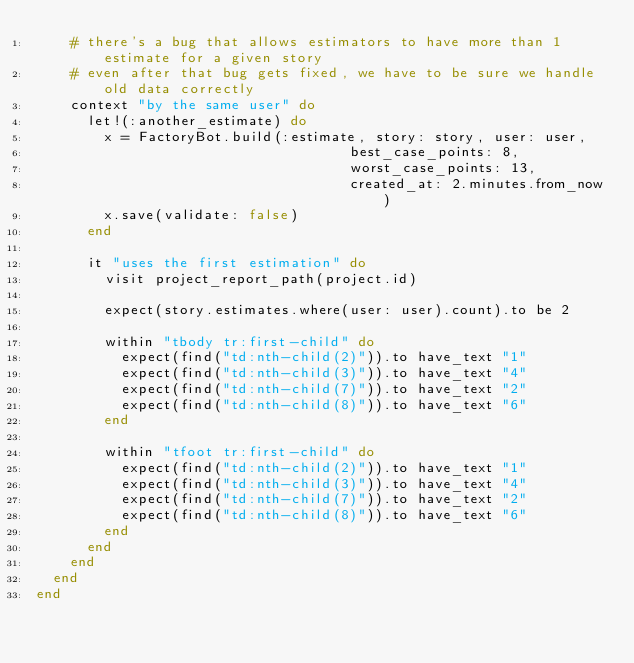Convert code to text. <code><loc_0><loc_0><loc_500><loc_500><_Ruby_>    # there's a bug that allows estimators to have more than 1 estimate for a given story
    # even after that bug gets fixed, we have to be sure we handle old data correctly
    context "by the same user" do
      let!(:another_estimate) do
        x = FactoryBot.build(:estimate, story: story, user: user,
                                     best_case_points: 8,
                                     worst_case_points: 13,
                                     created_at: 2.minutes.from_now)
        x.save(validate: false)
      end

      it "uses the first estimation" do
        visit project_report_path(project.id)

        expect(story.estimates.where(user: user).count).to be 2

        within "tbody tr:first-child" do
          expect(find("td:nth-child(2)")).to have_text "1"
          expect(find("td:nth-child(3)")).to have_text "4"
          expect(find("td:nth-child(7)")).to have_text "2"
          expect(find("td:nth-child(8)")).to have_text "6"
        end

        within "tfoot tr:first-child" do
          expect(find("td:nth-child(2)")).to have_text "1"
          expect(find("td:nth-child(3)")).to have_text "4"
          expect(find("td:nth-child(7)")).to have_text "2"
          expect(find("td:nth-child(8)")).to have_text "6"
        end
      end
    end
  end
end
</code> 